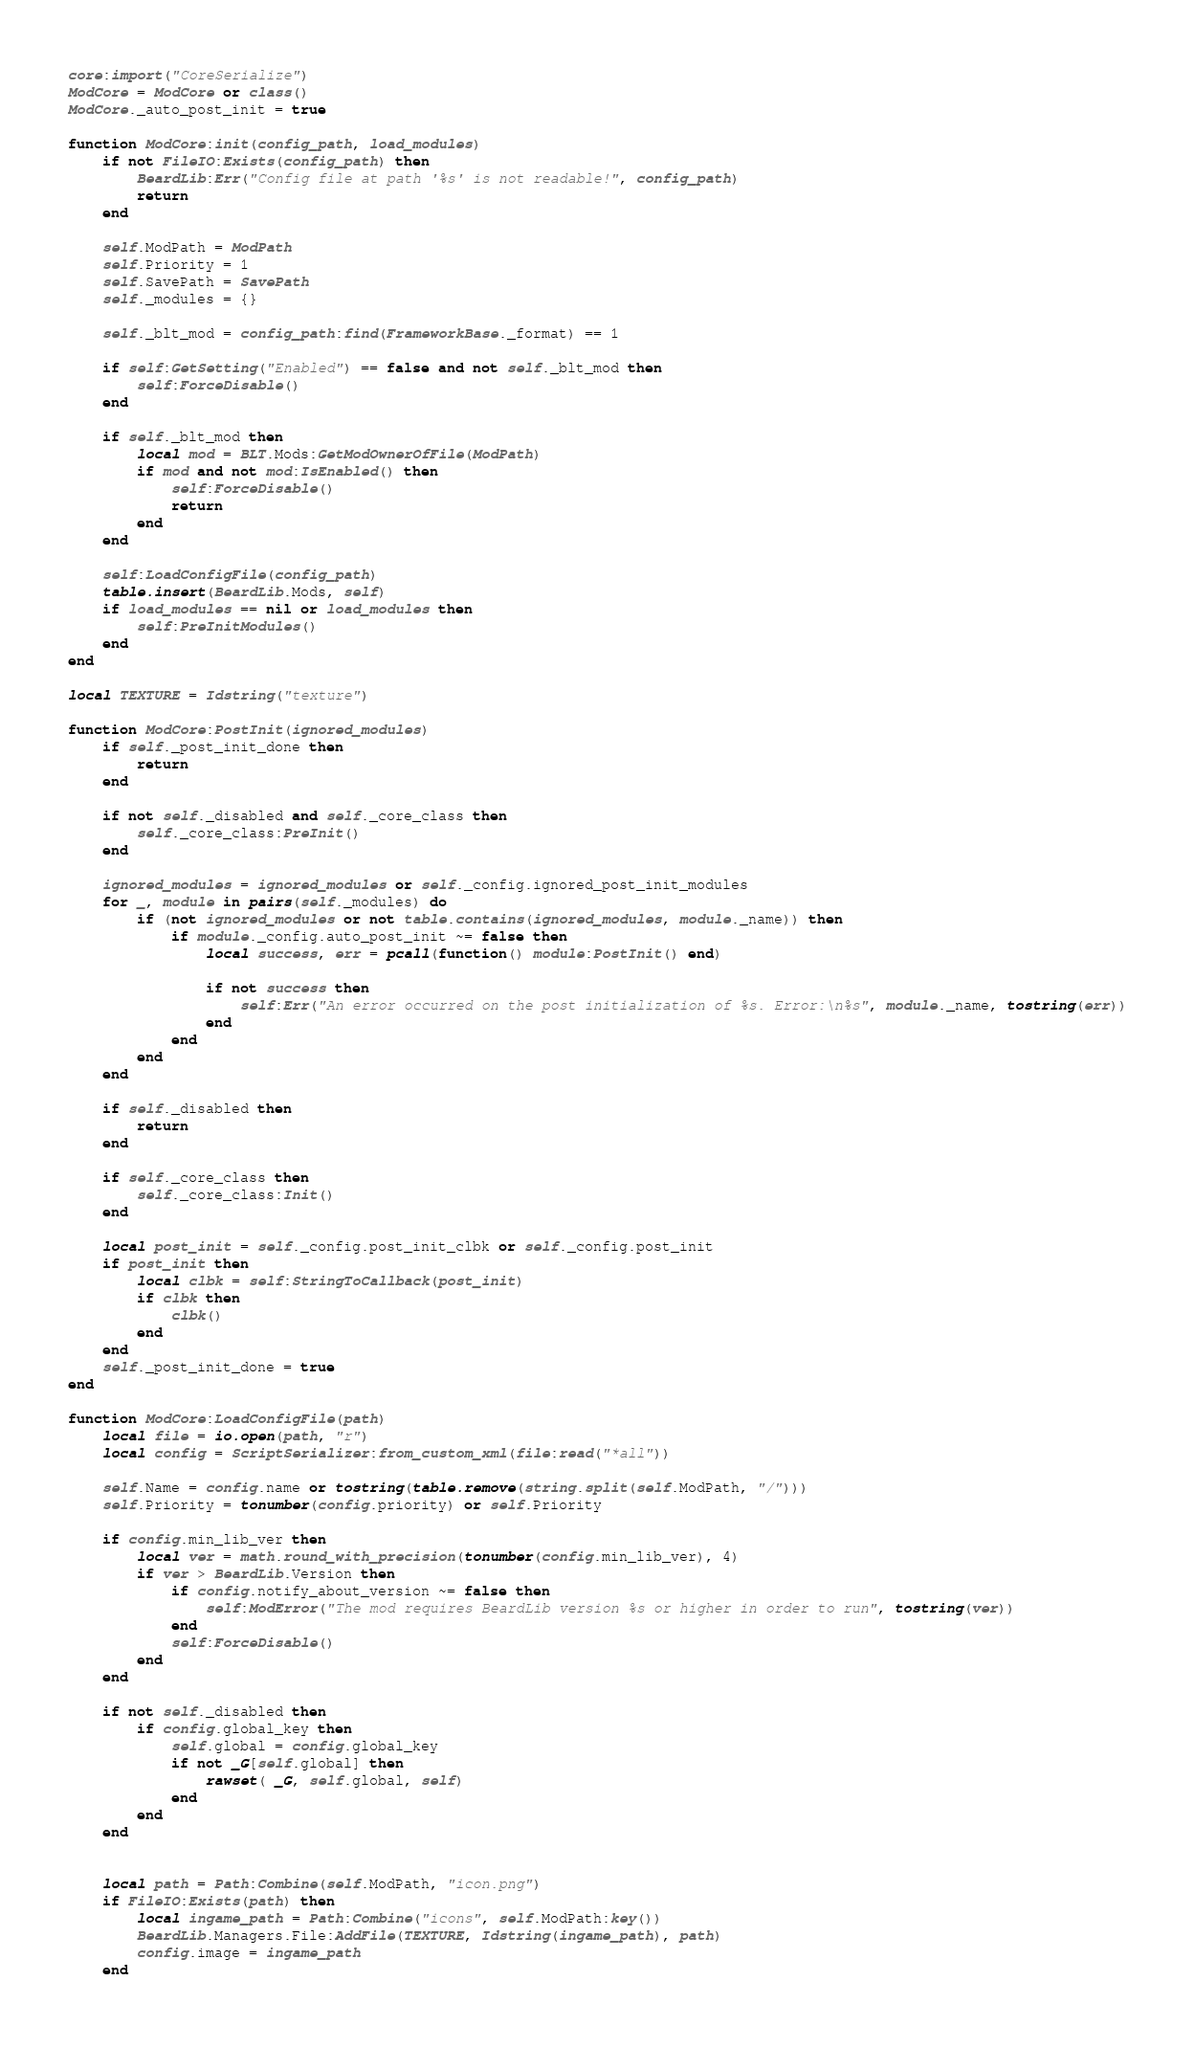Convert code to text. <code><loc_0><loc_0><loc_500><loc_500><_Lua_>core:import("CoreSerialize")
ModCore = ModCore or class()
ModCore._auto_post_init = true

function ModCore:init(config_path, load_modules)
    if not FileIO:Exists(config_path) then
        BeardLib:Err("Config file at path '%s' is not readable!", config_path)
        return
    end

	self.ModPath = ModPath
    self.Priority = 1
	self.SavePath = SavePath
    self._modules = {}

    self._blt_mod = config_path:find(FrameworkBase._format) == 1

    if self:GetSetting("Enabled") == false and not self._blt_mod then
        self:ForceDisable()
	end

    if self._blt_mod then
		local mod = BLT.Mods:GetModOwnerOfFile(ModPath)
		if mod and not mod:IsEnabled() then
			self:ForceDisable()
			return
		end
	end

	self:LoadConfigFile(config_path)
    table.insert(BeardLib.Mods, self)
    if load_modules == nil or load_modules then
        self:PreInitModules()
    end
end

local TEXTURE = Idstring("texture")

function ModCore:PostInit(ignored_modules)
    if self._post_init_done then
        return
	end

	if not self._disabled and self._core_class then
		self._core_class:PreInit()
    end

    ignored_modules = ignored_modules or self._config.ignored_post_init_modules
    for _, module in pairs(self._modules) do
        if (not ignored_modules or not table.contains(ignored_modules, module._name)) then
            if module._config.auto_post_init ~= false then
                local success, err = pcall(function() module:PostInit() end)

                if not success then
                    self:Err("An error occurred on the post initialization of %s. Error:\n%s", module._name, tostring(err))
                end
            end
        end
    end

    if self._disabled then
        return
    end

	if self._core_class then
		self._core_class:Init()
	end

	local post_init = self._config.post_init_clbk or self._config.post_init
    if post_init then
        local clbk = self:StringToCallback(post_init)
        if clbk then
            clbk()
        end
	end
	self._post_init_done = true
end

function ModCore:LoadConfigFile(path)
    local file = io.open(path, "r")
    local config = ScriptSerializer:from_custom_xml(file:read("*all"))

    self.Name = config.name or tostring(table.remove(string.split(self.ModPath, "/")))
    self.Priority = tonumber(config.priority) or self.Priority

    if config.min_lib_ver then
        local ver = math.round_with_precision(tonumber(config.min_lib_ver), 4)
        if ver > BeardLib.Version then
            if config.notify_about_version ~= false then
                self:ModError("The mod requires BeardLib version %s or higher in order to run", tostring(ver))
            end
            self:ForceDisable()
        end
    end

    if not self._disabled then
        if config.global_key then
            self.global = config.global_key
            if not _G[self.global] then
                rawset( _G, self.global, self)
            end
        end
    end


    local path = Path:Combine(self.ModPath, "icon.png")
    if FileIO:Exists(path) then
        local ingame_path = Path:Combine("icons", self.ModPath:key())
        BeardLib.Managers.File:AddFile(TEXTURE, Idstring(ingame_path), path)
        config.image = ingame_path
    end
</code> 